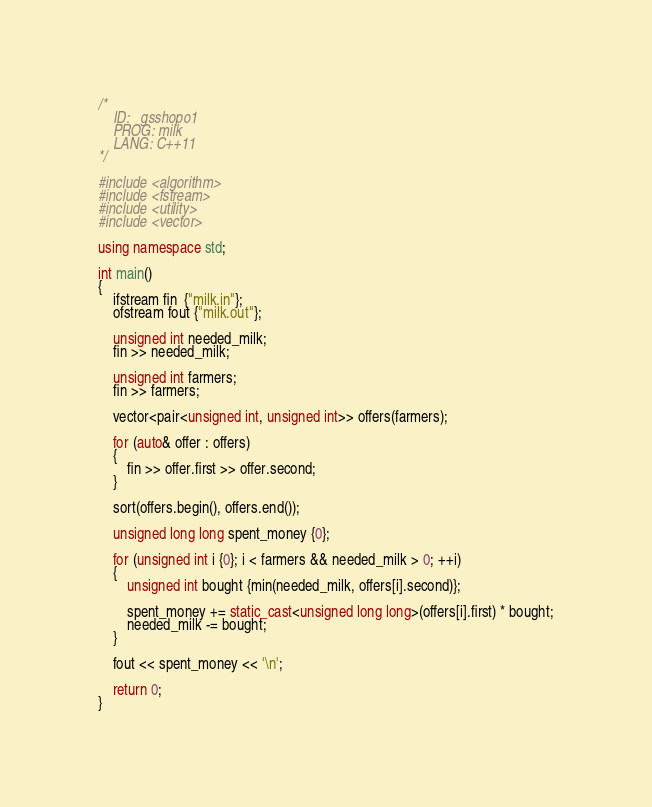Convert code to text. <code><loc_0><loc_0><loc_500><loc_500><_C++_>/*
    ID:   gsshopo1
    PROG: milk
    LANG: C++11
*/

#include <algorithm>
#include <fstream>
#include <utility>
#include <vector>

using namespace std;

int main()
{
    ifstream fin  {"milk.in"};
    ofstream fout {"milk.out"};

    unsigned int needed_milk;
    fin >> needed_milk;

    unsigned int farmers;
    fin >> farmers;

    vector<pair<unsigned int, unsigned int>> offers(farmers);

    for (auto& offer : offers)
    {
        fin >> offer.first >> offer.second;
    }

    sort(offers.begin(), offers.end());

    unsigned long long spent_money {0};

    for (unsigned int i {0}; i < farmers && needed_milk > 0; ++i)
    {
        unsigned int bought {min(needed_milk, offers[i].second)};

        spent_money += static_cast<unsigned long long>(offers[i].first) * bought;
        needed_milk -= bought;
    }

    fout << spent_money << '\n';

    return 0;
}
</code> 